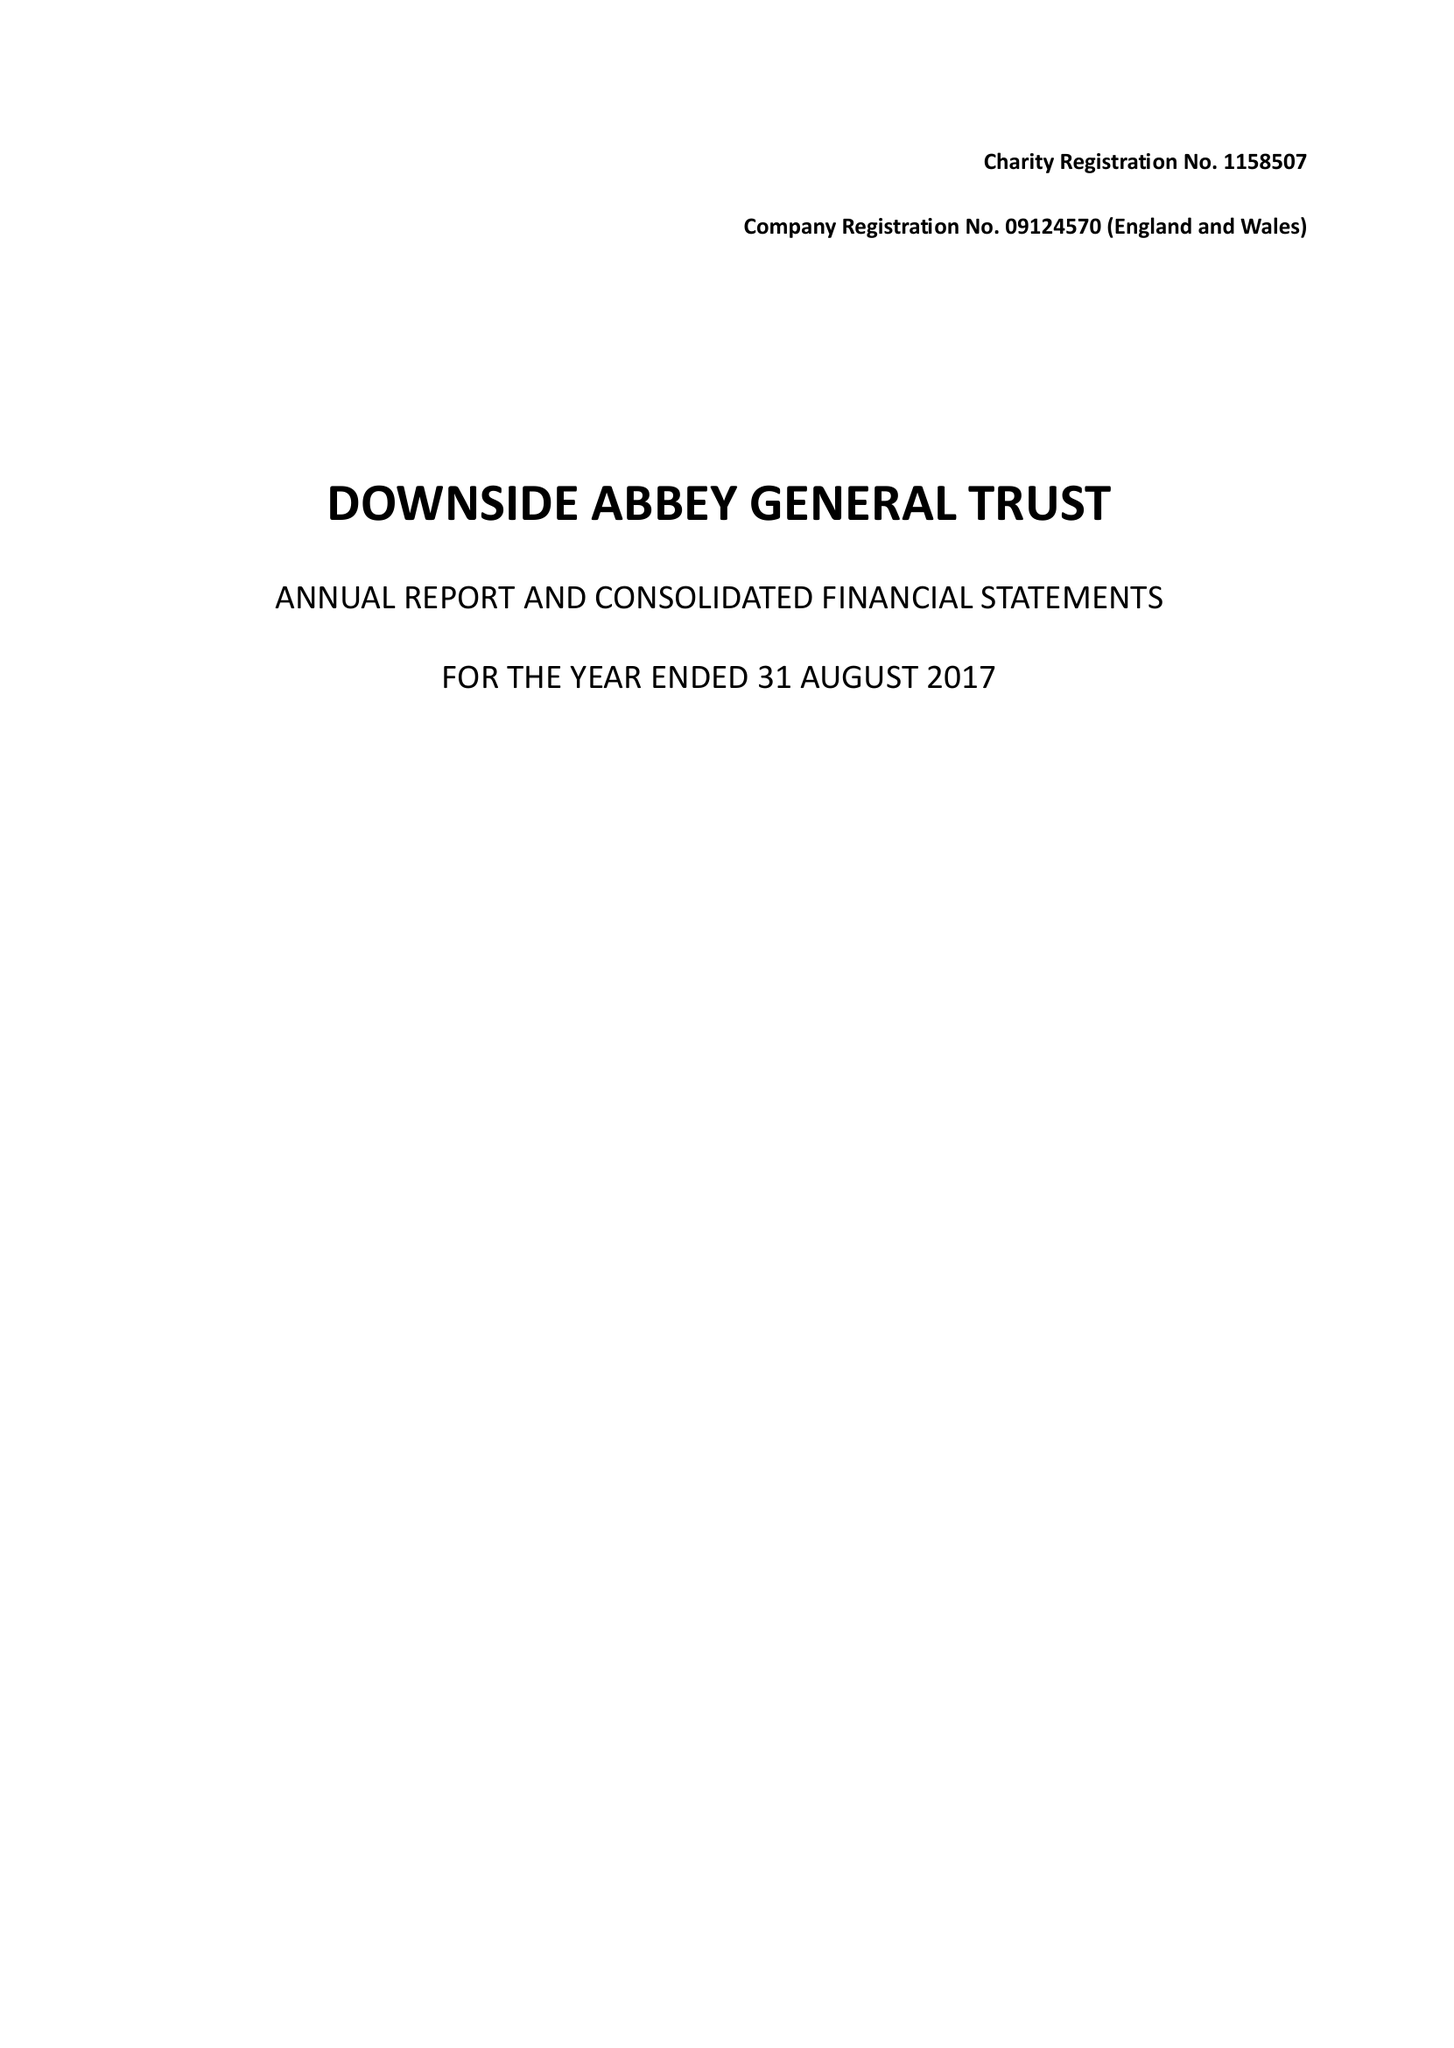What is the value for the income_annually_in_british_pounds?
Answer the question using a single word or phrase. 10488022.00 